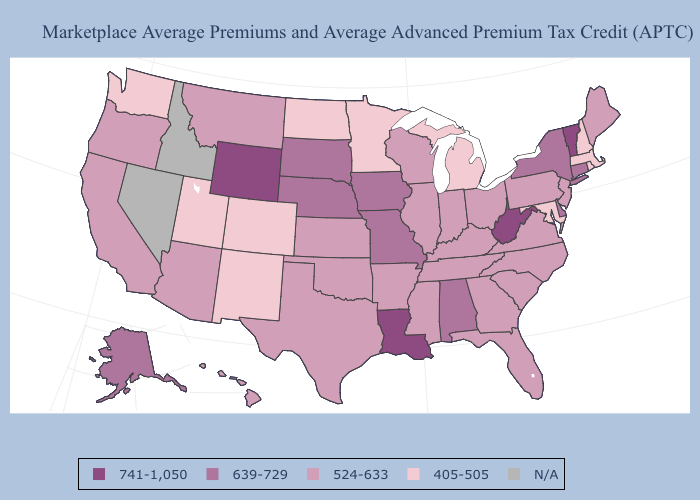Which states hav the highest value in the West?
Give a very brief answer. Wyoming. Among the states that border Iowa , which have the highest value?
Keep it brief. Missouri, Nebraska, South Dakota. Does West Virginia have the highest value in the USA?
Short answer required. Yes. Does Louisiana have the lowest value in the USA?
Short answer required. No. What is the value of Iowa?
Concise answer only. 639-729. Does the map have missing data?
Concise answer only. Yes. What is the lowest value in states that border California?
Answer briefly. 524-633. How many symbols are there in the legend?
Short answer required. 5. Name the states that have a value in the range 639-729?
Keep it brief. Alabama, Alaska, Connecticut, Delaware, Iowa, Missouri, Nebraska, New York, South Dakota. Does the map have missing data?
Quick response, please. Yes. What is the highest value in states that border Montana?
Be succinct. 741-1,050. How many symbols are there in the legend?
Give a very brief answer. 5. Does South Carolina have the highest value in the USA?
Be succinct. No. 